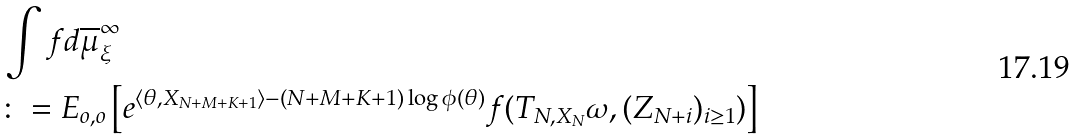Convert formula to latex. <formula><loc_0><loc_0><loc_500><loc_500>& \int f d \overline { \mu } _ { \xi } ^ { \infty } \\ & \colon = E _ { o , o } \left [ e ^ { \langle \theta , X _ { N + M + K + 1 } \rangle - ( N + M + K + 1 ) \log \phi ( \theta ) } f ( T _ { N , X _ { N } } \omega , ( Z _ { N + i } ) _ { i \geq 1 } ) \right ]</formula> 